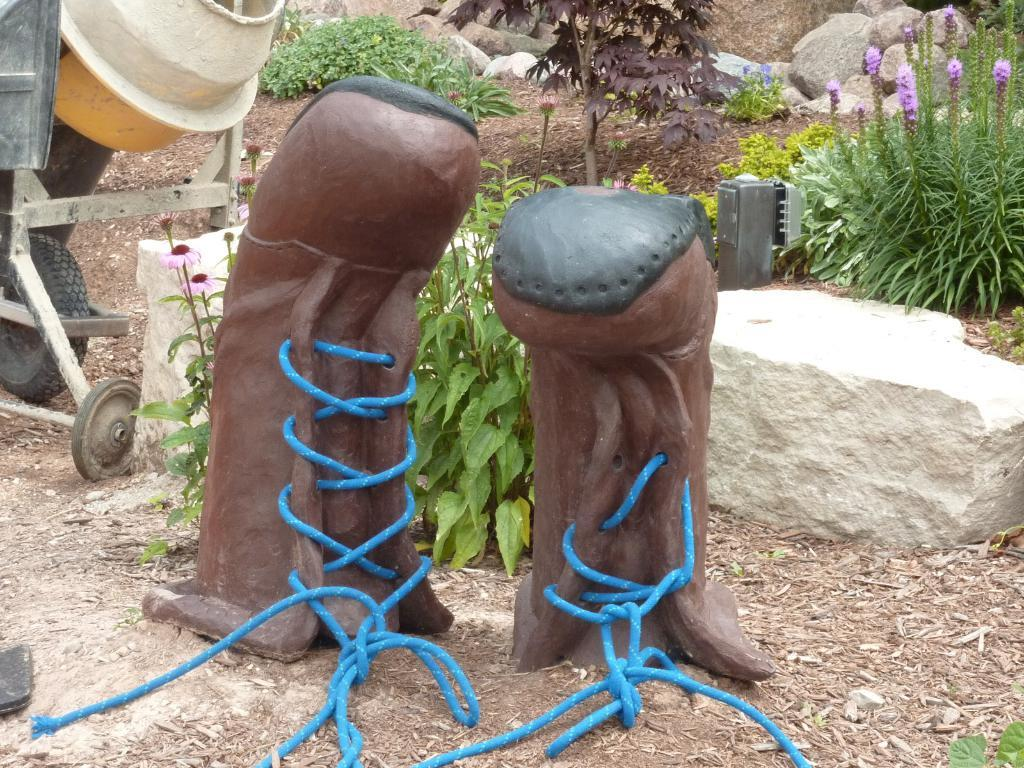What type of sculptures can be seen in the image? There are sculptures of shoes with ropes in the image. What can be seen in the background of the image? Plants with flowers, rocks, grass, and a cement concrete mixer vehicle are present in the background of the image. How many cats can be seen in the image? There are no cats present in the image. What is the condition of the sculptor's throat while creating the shoe sculptures? There is no information about the sculptor's throat in the image, as it focuses on the sculptures themselves and the background elements. 